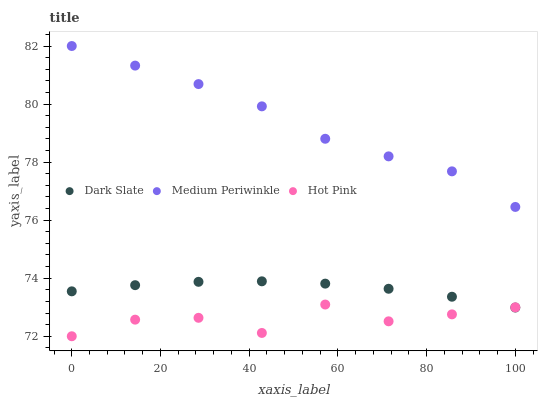Does Hot Pink have the minimum area under the curve?
Answer yes or no. Yes. Does Medium Periwinkle have the maximum area under the curve?
Answer yes or no. Yes. Does Medium Periwinkle have the minimum area under the curve?
Answer yes or no. No. Does Hot Pink have the maximum area under the curve?
Answer yes or no. No. Is Dark Slate the smoothest?
Answer yes or no. Yes. Is Hot Pink the roughest?
Answer yes or no. Yes. Is Medium Periwinkle the smoothest?
Answer yes or no. No. Is Medium Periwinkle the roughest?
Answer yes or no. No. Does Hot Pink have the lowest value?
Answer yes or no. Yes. Does Medium Periwinkle have the lowest value?
Answer yes or no. No. Does Medium Periwinkle have the highest value?
Answer yes or no. Yes. Does Hot Pink have the highest value?
Answer yes or no. No. Is Dark Slate less than Medium Periwinkle?
Answer yes or no. Yes. Is Medium Periwinkle greater than Hot Pink?
Answer yes or no. Yes. Does Dark Slate intersect Hot Pink?
Answer yes or no. Yes. Is Dark Slate less than Hot Pink?
Answer yes or no. No. Is Dark Slate greater than Hot Pink?
Answer yes or no. No. Does Dark Slate intersect Medium Periwinkle?
Answer yes or no. No. 